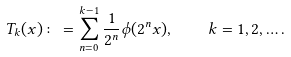Convert formula to latex. <formula><loc_0><loc_0><loc_500><loc_500>T _ { k } ( x ) \colon = \sum _ { n = 0 } ^ { k - 1 } \frac { 1 } { 2 ^ { n } } \phi ( 2 ^ { n } x ) , \quad k = 1 , 2 , \dots .</formula> 